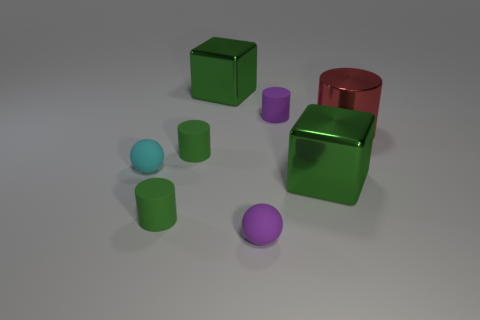There is a matte cylinder behind the big shiny cylinder; does it have the same color as the tiny matte sphere that is on the right side of the tiny cyan object?
Provide a short and direct response. Yes. Are the tiny object that is to the right of the tiny purple rubber sphere and the large cylinder made of the same material?
Your answer should be very brief. No. Does the small green object in front of the tiny cyan sphere have the same shape as the purple rubber thing that is behind the red shiny cylinder?
Your answer should be very brief. Yes. Are there fewer tiny rubber cylinders that are right of the purple sphere than large metal things behind the tiny cyan ball?
Keep it short and to the point. Yes. There is another tiny sphere that is the same material as the tiny cyan ball; what color is it?
Give a very brief answer. Purple. There is a large shiny block left of the tiny rubber object behind the big cylinder; what color is it?
Offer a very short reply. Green. What shape is the purple matte object that is the same size as the purple ball?
Provide a short and direct response. Cylinder. How many tiny spheres are on the right side of the large shiny object behind the small purple cylinder?
Offer a terse response. 1. What number of other things are there of the same material as the purple cylinder
Offer a very short reply. 4. The red metallic object that is right of the large green metal cube in front of the large metallic cylinder is what shape?
Ensure brevity in your answer.  Cylinder. 